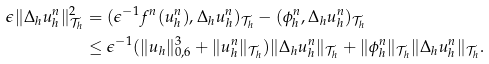Convert formula to latex. <formula><loc_0><loc_0><loc_500><loc_500>\epsilon \| \Delta _ { h } u _ { h } ^ { n } \| ^ { 2 } _ { \mathcal { T } _ { h } } & = ( \epsilon ^ { - 1 } f ^ { n } ( u ^ { n } _ { h } ) , \Delta _ { h } u ^ { n } _ { h } ) _ { \mathcal { T } _ { h } } - ( \phi _ { h } ^ { n } , \Delta _ { h } u ^ { n } _ { h } ) _ { \mathcal { T } _ { h } } \\ & \leq \epsilon ^ { - 1 } ( \| u _ { h } \| _ { 0 , 6 } ^ { 3 } + \| u _ { h } ^ { n } \| _ { \mathcal { T } _ { h } } ) \| \Delta _ { h } u _ { h } ^ { n } \| _ { \mathcal { T } _ { h } } + \| \phi _ { h } ^ { n } \| _ { \mathcal { T } _ { h } } \| \Delta _ { h } u _ { h } ^ { n } \| _ { \mathcal { T } _ { h } } .</formula> 